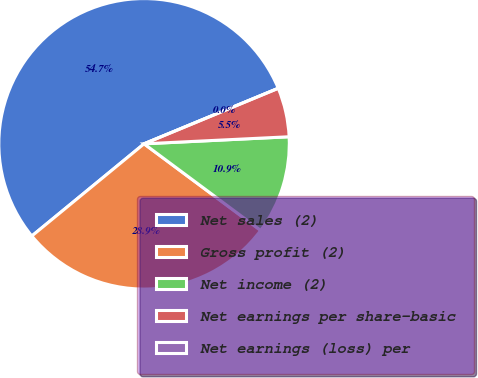Convert chart to OTSL. <chart><loc_0><loc_0><loc_500><loc_500><pie_chart><fcel>Net sales (2)<fcel>Gross profit (2)<fcel>Net income (2)<fcel>Net earnings per share-basic<fcel>Net earnings (loss) per<nl><fcel>54.7%<fcel>28.89%<fcel>10.94%<fcel>5.47%<fcel>0.0%<nl></chart> 